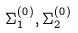Convert formula to latex. <formula><loc_0><loc_0><loc_500><loc_500>\Sigma _ { 1 } ^ { ( 0 ) } , \Sigma _ { 2 } ^ { ( 0 ) }</formula> 